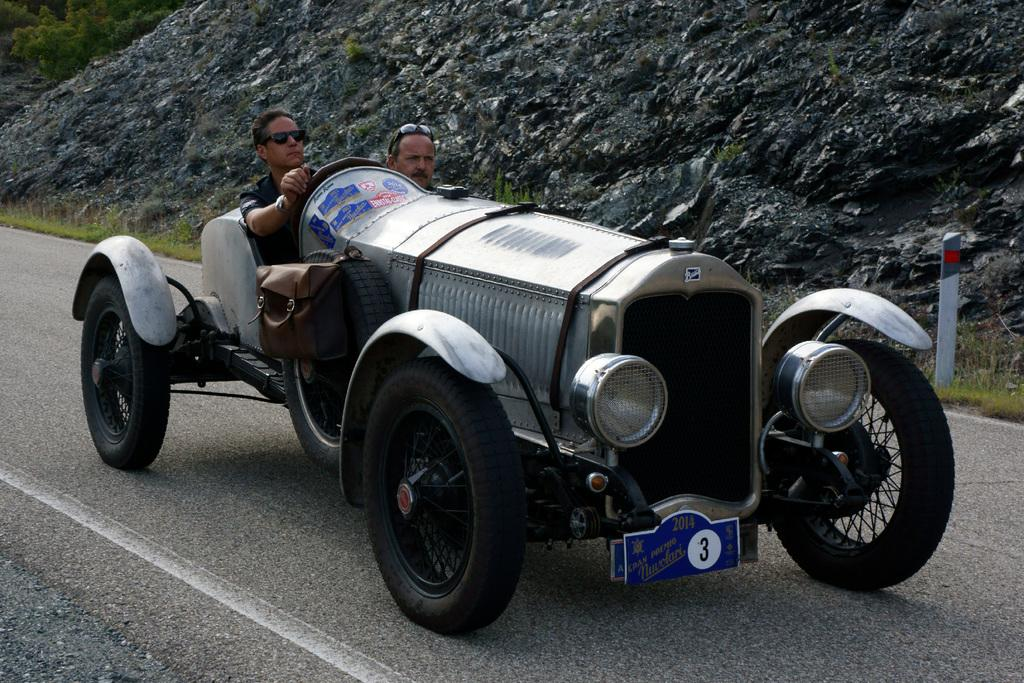Where was the image taken? The image is taken outdoors. What is the weather like in the image? It is sunny in the image. How many people are in the image? There are two persons in the image. What are the two persons doing in the image? The two persons are riding a vehicle. What can be seen in the background of the image? There is a mountain in the background of the image. How many pieces of chalk are being used by the persons in the image? There is no chalk present in the image. What type of sack is being carried by the persons in the image? There is no sack present in the image. 